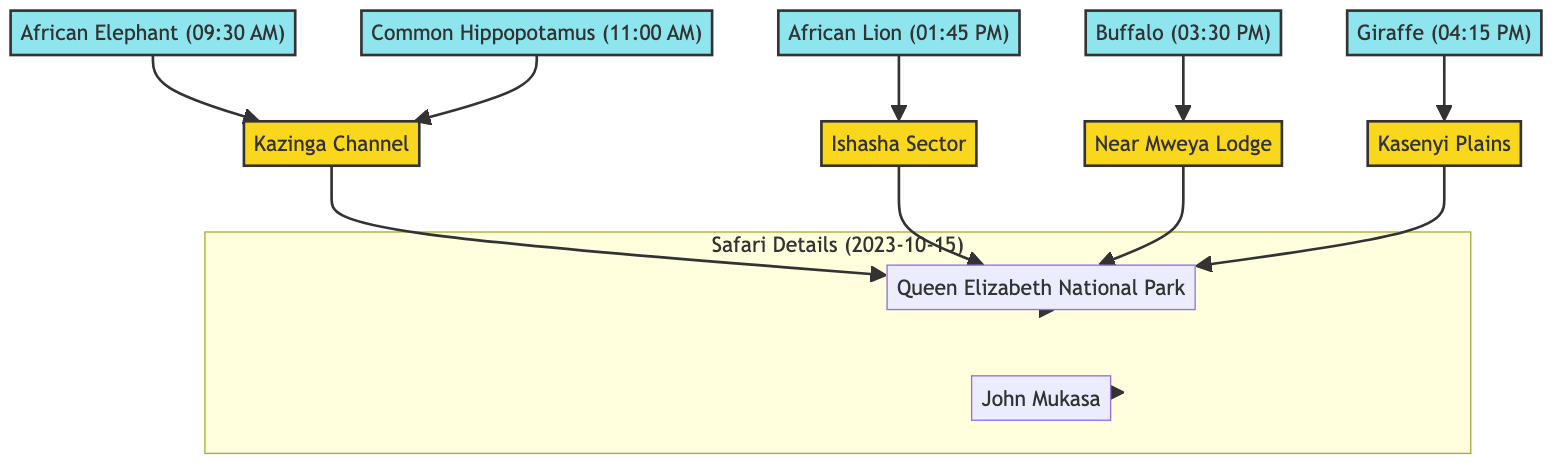What is the date of the safari? The date of the safari is indicated in the "Safari Details" section of the diagram, which shows the date as 2023-10-15.
Answer: 2023-10-15 Who was the safari guide? The diagram specifies the safari guide's name in the "Safari Details" section, showing that it is John Mukasa.
Answer: John Mukasa How many species were observed during the safari? By counting the number of species listed under the "Sightings," we see that there are five species: African Elephant, African Lion, Common Hippopotamus, Buffalo, and Giraffe.
Answer: 5 What time was the African Elephant sighted? The time for the African Elephant is noted next to its species in the diagram, where it clearly states the time as 09:30 AM.
Answer: 09:30 AM Which location had the Common Hippopotamus sighting? The diagram connects the Common Hippopotamus to the Kazinga Channel, indicating that this species was sighted there according to the location details.
Answer: Kazinga Channel Which species was spotted in the Ishasha Sector? The diagram shows that the African Lion is the species associated with the Ishasha Sector, indicating the location where it was seen.
Answer: African Lion List the species sighted after 3:00 PM. By inspecting the sighting times in the diagram, we note that Buffalo at 03:30 PM and Giraffe at 04:15 PM were sighted after 3:00 PM.
Answer: Buffalo, Giraffe How are the locations connected to the national park? The diagram indicates that each location (Kazinga Channel, Ishasha Sector, Near Mweya Lodge, and Kasenyi Plains) has links to the Queen Elizabeth National Park, illustrating their association with the park.
Answer: Queen Elizabeth National Park Which species was observed at Kazinga Channel? The diagram shows two species connected to Kazinga Channel: African Elephant and Common Hippopotamus, indicating both were sighted at this location.
Answer: African Elephant, Common Hippopotamus 